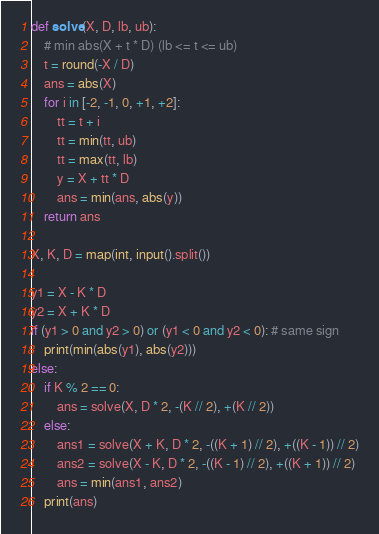Convert code to text. <code><loc_0><loc_0><loc_500><loc_500><_Python_>def solve(X, D, lb, ub):
    # min abs(X + t * D) (lb <= t <= ub)
    t = round(-X / D)
    ans = abs(X)
    for i in [-2, -1, 0, +1, +2]:
        tt = t + i
        tt = min(tt, ub)
        tt = max(tt, lb)
        y = X + tt * D
        ans = min(ans, abs(y))
    return ans

X, K, D = map(int, input().split())

y1 = X - K * D
y2 = X + K * D
if (y1 > 0 and y2 > 0) or (y1 < 0 and y2 < 0): # same sign
    print(min(abs(y1), abs(y2)))
else:
    if K % 2 == 0:
        ans = solve(X, D * 2, -(K // 2), +(K // 2))
    else:
        ans1 = solve(X + K, D * 2, -((K + 1) // 2), +((K - 1)) // 2)
        ans2 = solve(X - K, D * 2, -((K - 1) // 2), +((K + 1)) // 2)
        ans = min(ans1, ans2)
    print(ans)

</code> 